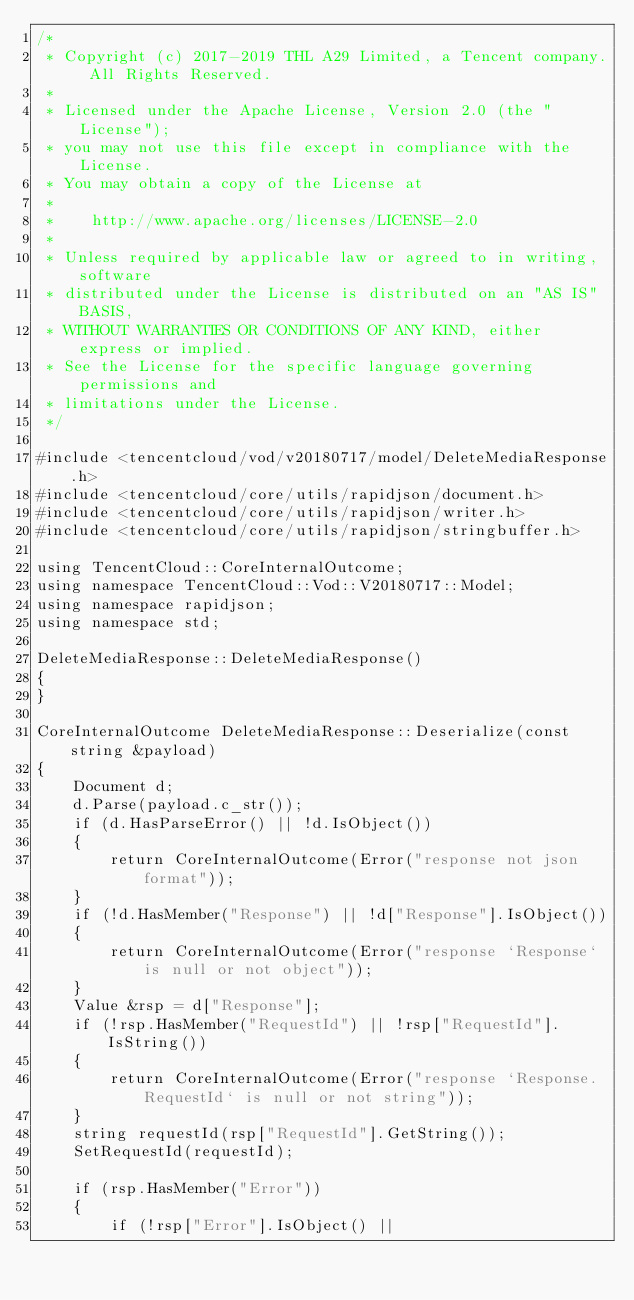<code> <loc_0><loc_0><loc_500><loc_500><_C++_>/*
 * Copyright (c) 2017-2019 THL A29 Limited, a Tencent company. All Rights Reserved.
 *
 * Licensed under the Apache License, Version 2.0 (the "License");
 * you may not use this file except in compliance with the License.
 * You may obtain a copy of the License at
 *
 *    http://www.apache.org/licenses/LICENSE-2.0
 *
 * Unless required by applicable law or agreed to in writing, software
 * distributed under the License is distributed on an "AS IS" BASIS,
 * WITHOUT WARRANTIES OR CONDITIONS OF ANY KIND, either express or implied.
 * See the License for the specific language governing permissions and
 * limitations under the License.
 */

#include <tencentcloud/vod/v20180717/model/DeleteMediaResponse.h>
#include <tencentcloud/core/utils/rapidjson/document.h>
#include <tencentcloud/core/utils/rapidjson/writer.h>
#include <tencentcloud/core/utils/rapidjson/stringbuffer.h>

using TencentCloud::CoreInternalOutcome;
using namespace TencentCloud::Vod::V20180717::Model;
using namespace rapidjson;
using namespace std;

DeleteMediaResponse::DeleteMediaResponse()
{
}

CoreInternalOutcome DeleteMediaResponse::Deserialize(const string &payload)
{
    Document d;
    d.Parse(payload.c_str());
    if (d.HasParseError() || !d.IsObject())
    {
        return CoreInternalOutcome(Error("response not json format"));
    }
    if (!d.HasMember("Response") || !d["Response"].IsObject())
    {
        return CoreInternalOutcome(Error("response `Response` is null or not object"));
    }
    Value &rsp = d["Response"];
    if (!rsp.HasMember("RequestId") || !rsp["RequestId"].IsString())
    {
        return CoreInternalOutcome(Error("response `Response.RequestId` is null or not string"));
    }
    string requestId(rsp["RequestId"].GetString());
    SetRequestId(requestId);

    if (rsp.HasMember("Error"))
    {
        if (!rsp["Error"].IsObject() ||</code> 